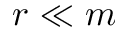<formula> <loc_0><loc_0><loc_500><loc_500>r \ll m</formula> 